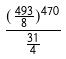<formula> <loc_0><loc_0><loc_500><loc_500>\frac { ( \frac { 4 9 3 } { 8 } ) ^ { 4 7 0 } } { \frac { 3 1 } { 4 } }</formula> 